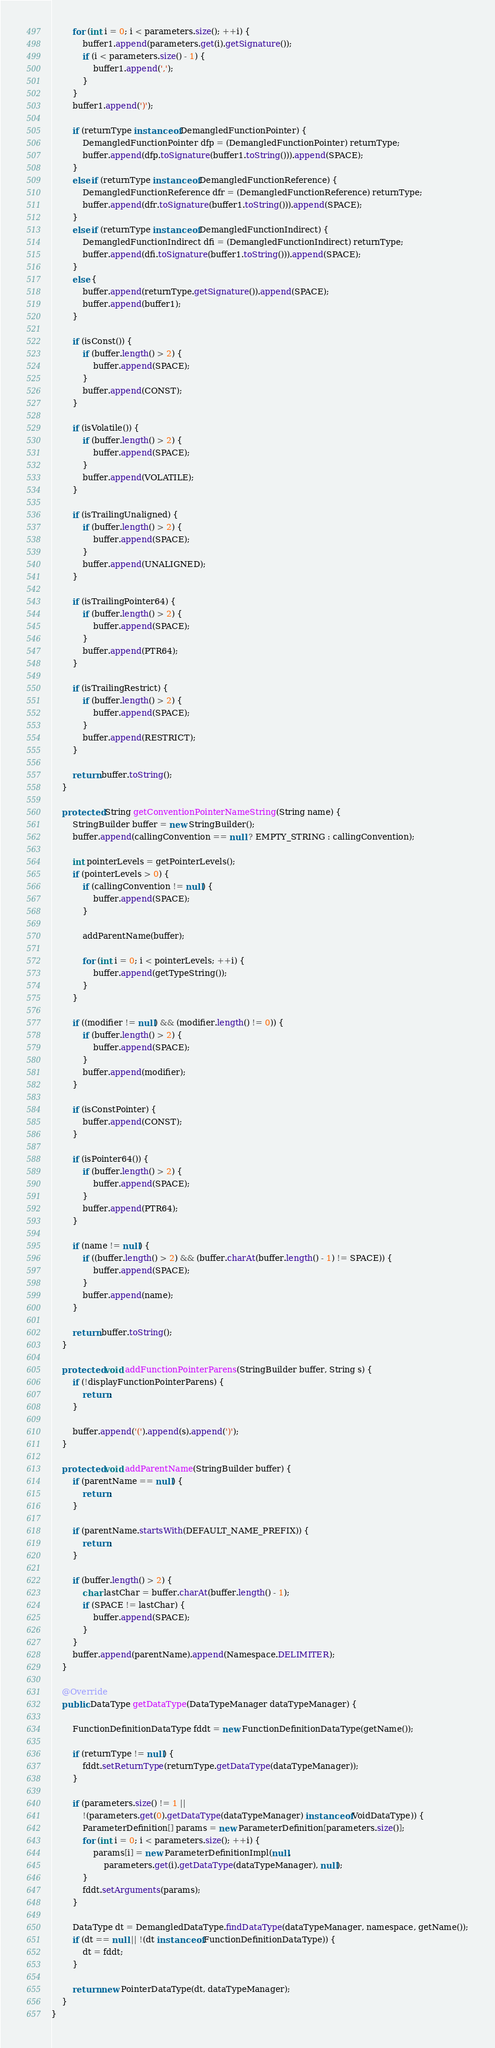<code> <loc_0><loc_0><loc_500><loc_500><_Java_>		for (int i = 0; i < parameters.size(); ++i) {
			buffer1.append(parameters.get(i).getSignature());
			if (i < parameters.size() - 1) {
				buffer1.append(',');
			}
		}
		buffer1.append(')');

		if (returnType instanceof DemangledFunctionPointer) {
			DemangledFunctionPointer dfp = (DemangledFunctionPointer) returnType;
			buffer.append(dfp.toSignature(buffer1.toString())).append(SPACE);
		}
		else if (returnType instanceof DemangledFunctionReference) {
			DemangledFunctionReference dfr = (DemangledFunctionReference) returnType;
			buffer.append(dfr.toSignature(buffer1.toString())).append(SPACE);
		}
		else if (returnType instanceof DemangledFunctionIndirect) {
			DemangledFunctionIndirect dfi = (DemangledFunctionIndirect) returnType;
			buffer.append(dfi.toSignature(buffer1.toString())).append(SPACE);
		}
		else {
			buffer.append(returnType.getSignature()).append(SPACE);
			buffer.append(buffer1);
		}

		if (isConst()) {
			if (buffer.length() > 2) {
				buffer.append(SPACE);
			}
			buffer.append(CONST);
		}

		if (isVolatile()) {
			if (buffer.length() > 2) {
				buffer.append(SPACE);
			}
			buffer.append(VOLATILE);
		}

		if (isTrailingUnaligned) {
			if (buffer.length() > 2) {
				buffer.append(SPACE);
			}
			buffer.append(UNALIGNED);
		}

		if (isTrailingPointer64) {
			if (buffer.length() > 2) {
				buffer.append(SPACE);
			}
			buffer.append(PTR64);
		}

		if (isTrailingRestrict) {
			if (buffer.length() > 2) {
				buffer.append(SPACE);
			}
			buffer.append(RESTRICT);
		}

		return buffer.toString();
	}

	protected String getConventionPointerNameString(String name) {
		StringBuilder buffer = new StringBuilder();
		buffer.append(callingConvention == null ? EMPTY_STRING : callingConvention);

		int pointerLevels = getPointerLevels();
		if (pointerLevels > 0) {
			if (callingConvention != null) {
				buffer.append(SPACE);
			}

			addParentName(buffer);

			for (int i = 0; i < pointerLevels; ++i) {
				buffer.append(getTypeString());
			}
		}

		if ((modifier != null) && (modifier.length() != 0)) {
			if (buffer.length() > 2) {
				buffer.append(SPACE);
			}
			buffer.append(modifier);
		}

		if (isConstPointer) {
			buffer.append(CONST);
		}

		if (isPointer64()) {
			if (buffer.length() > 2) {
				buffer.append(SPACE);
			}
			buffer.append(PTR64);
		}

		if (name != null) {
			if ((buffer.length() > 2) && (buffer.charAt(buffer.length() - 1) != SPACE)) {
				buffer.append(SPACE);
			}
			buffer.append(name);
		}

		return buffer.toString();
	}

	protected void addFunctionPointerParens(StringBuilder buffer, String s) {
		if (!displayFunctionPointerParens) {
			return;
		}

		buffer.append('(').append(s).append(')');
	}

	protected void addParentName(StringBuilder buffer) {
		if (parentName == null) {
			return;
		}

		if (parentName.startsWith(DEFAULT_NAME_PREFIX)) {
			return;
		}

		if (buffer.length() > 2) {
			char lastChar = buffer.charAt(buffer.length() - 1);
			if (SPACE != lastChar) {
				buffer.append(SPACE);
			}
		}
		buffer.append(parentName).append(Namespace.DELIMITER);
	}

	@Override
	public DataType getDataType(DataTypeManager dataTypeManager) {

		FunctionDefinitionDataType fddt = new FunctionDefinitionDataType(getName());

		if (returnType != null) {
			fddt.setReturnType(returnType.getDataType(dataTypeManager));
		}

		if (parameters.size() != 1 ||
			!(parameters.get(0).getDataType(dataTypeManager) instanceof VoidDataType)) {
			ParameterDefinition[] params = new ParameterDefinition[parameters.size()];
			for (int i = 0; i < parameters.size(); ++i) {
				params[i] = new ParameterDefinitionImpl(null,
					parameters.get(i).getDataType(dataTypeManager), null);
			}
			fddt.setArguments(params);
		}

		DataType dt = DemangledDataType.findDataType(dataTypeManager, namespace, getName());
		if (dt == null || !(dt instanceof FunctionDefinitionDataType)) {
			dt = fddt;
		}

		return new PointerDataType(dt, dataTypeManager);
	}
}
</code> 